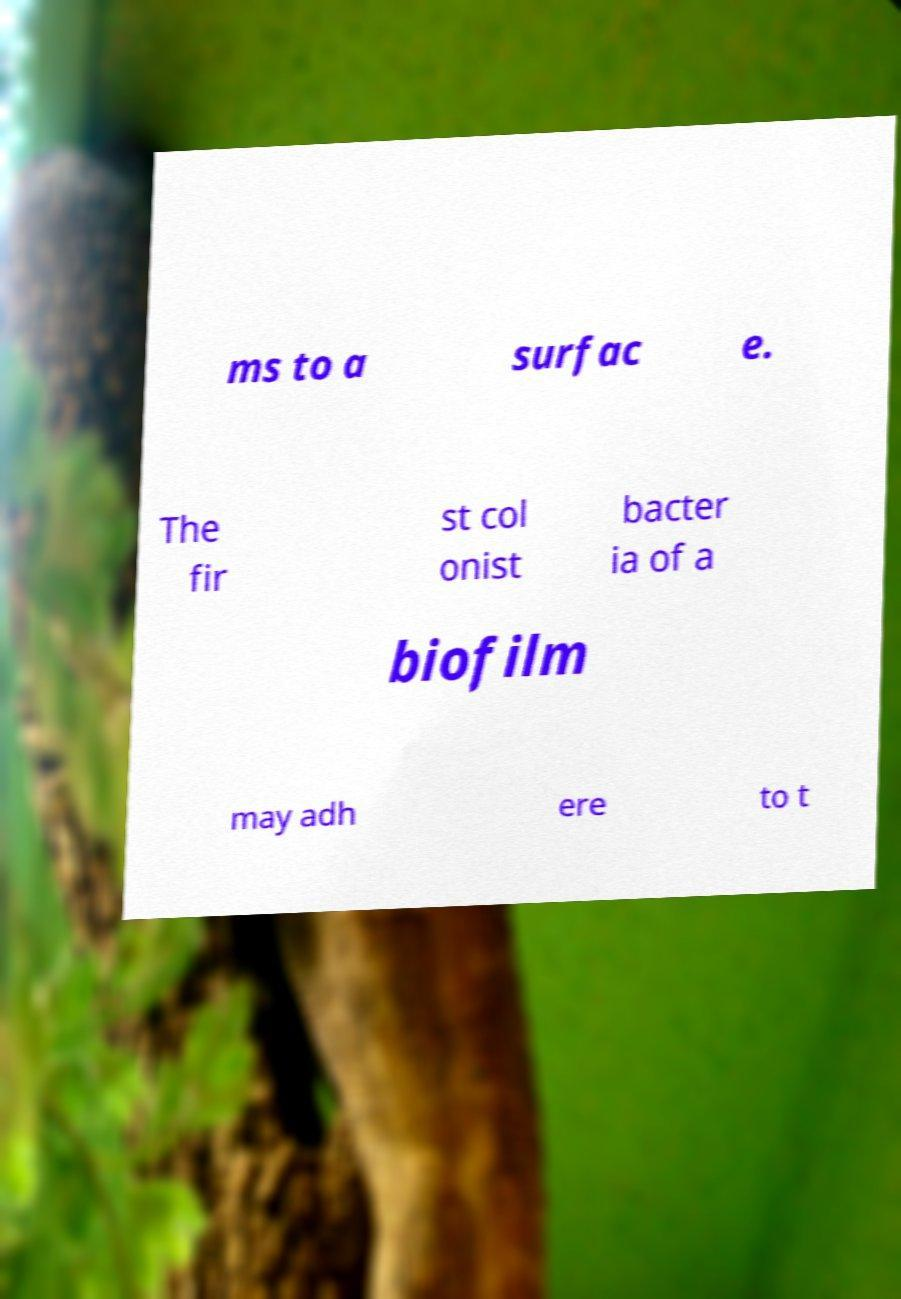I need the written content from this picture converted into text. Can you do that? ms to a surfac e. The fir st col onist bacter ia of a biofilm may adh ere to t 